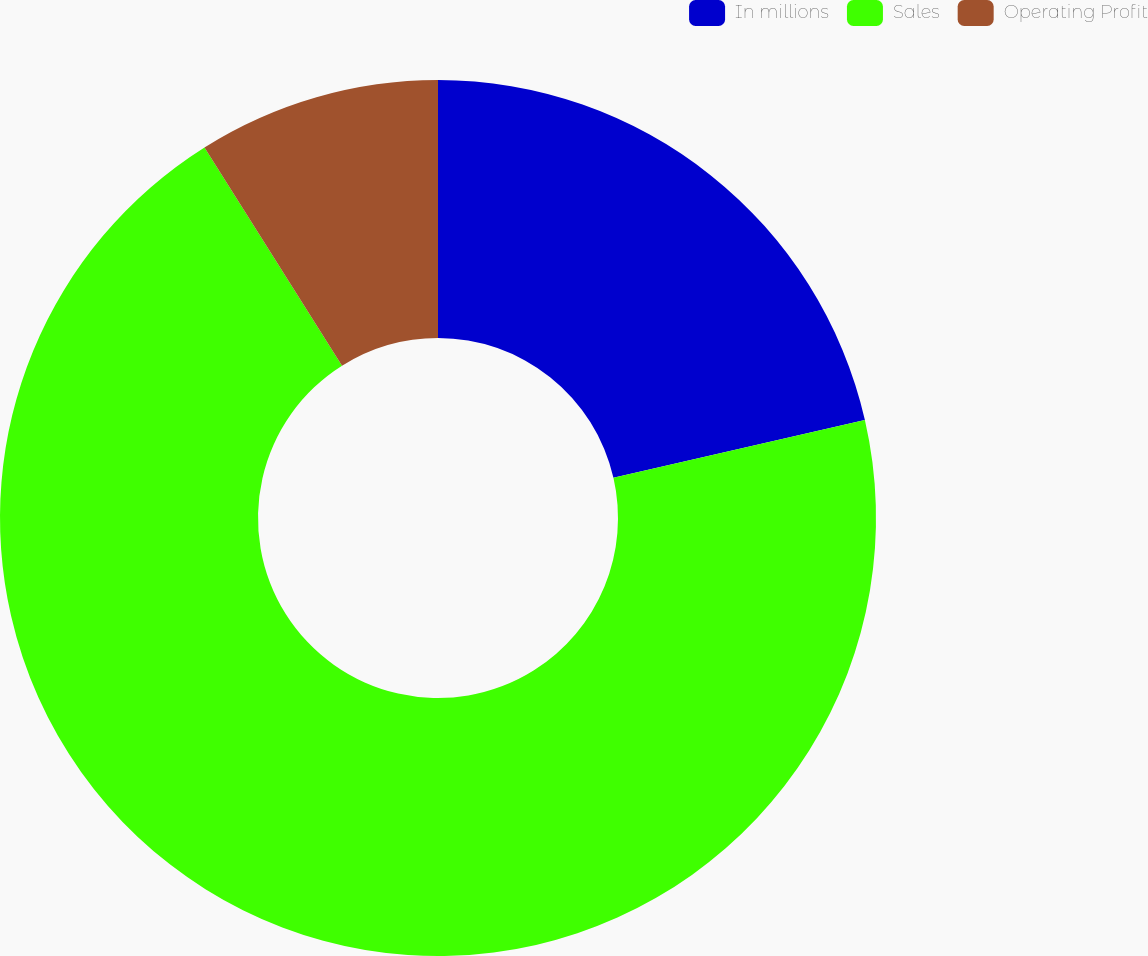<chart> <loc_0><loc_0><loc_500><loc_500><pie_chart><fcel>In millions<fcel>Sales<fcel>Operating Profit<nl><fcel>21.41%<fcel>69.65%<fcel>8.95%<nl></chart> 